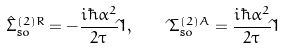<formula> <loc_0><loc_0><loc_500><loc_500>\hat { \Sigma } _ { \text  so}^{(2)R}=-\frac{i\hbar{ } \alpha ^ { 2 } } { 2 \tau } \hat { } 1 , \quad \hat { } \Sigma _ { \text  so}^{(2)A}=\frac{i\hbar{ } \alpha ^ { 2 } } { 2 \tau } \hat { } 1</formula> 